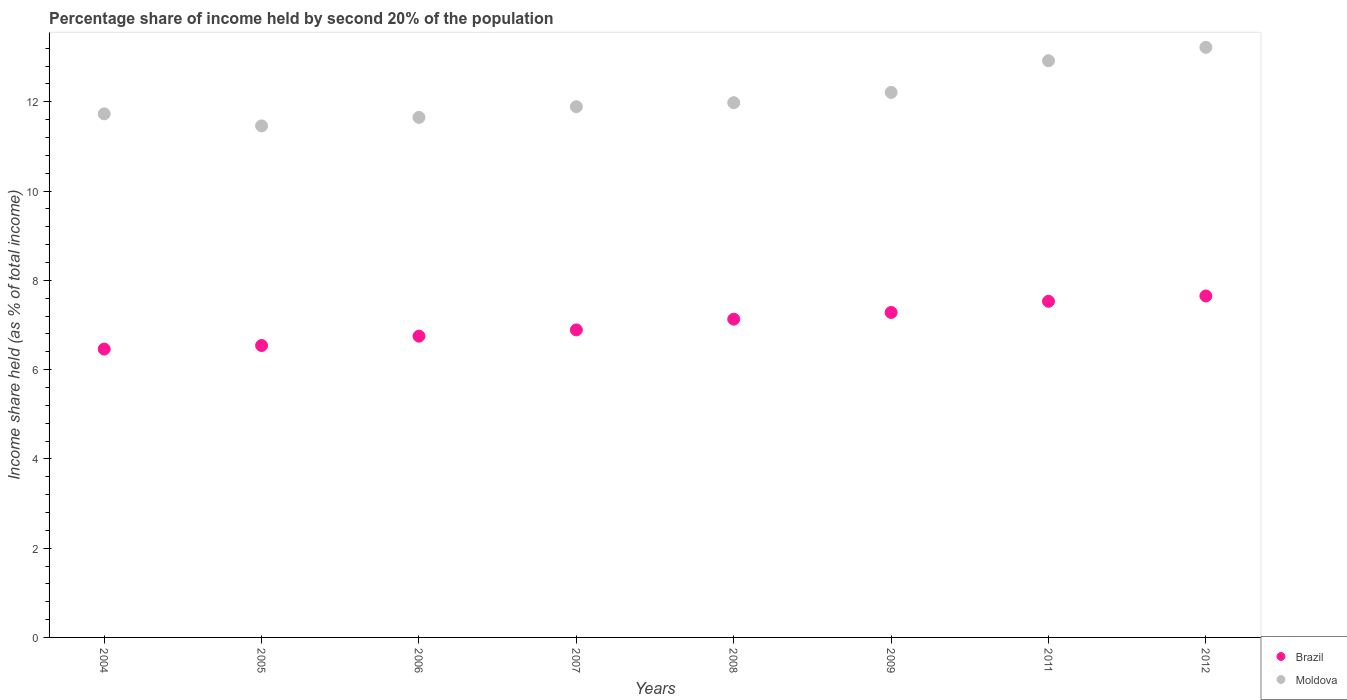How many different coloured dotlines are there?
Provide a short and direct response. 2. What is the share of income held by second 20% of the population in Moldova in 2007?
Make the answer very short. 11.89. Across all years, what is the maximum share of income held by second 20% of the population in Moldova?
Ensure brevity in your answer.  13.22. Across all years, what is the minimum share of income held by second 20% of the population in Moldova?
Offer a very short reply. 11.46. What is the total share of income held by second 20% of the population in Moldova in the graph?
Give a very brief answer. 97.06. What is the difference between the share of income held by second 20% of the population in Moldova in 2005 and that in 2011?
Your answer should be compact. -1.46. What is the difference between the share of income held by second 20% of the population in Moldova in 2006 and the share of income held by second 20% of the population in Brazil in 2009?
Offer a terse response. 4.37. What is the average share of income held by second 20% of the population in Moldova per year?
Make the answer very short. 12.13. In the year 2006, what is the difference between the share of income held by second 20% of the population in Brazil and share of income held by second 20% of the population in Moldova?
Offer a very short reply. -4.9. In how many years, is the share of income held by second 20% of the population in Brazil greater than 1.6 %?
Offer a terse response. 8. What is the ratio of the share of income held by second 20% of the population in Moldova in 2005 to that in 2009?
Your answer should be very brief. 0.94. Is the difference between the share of income held by second 20% of the population in Brazil in 2004 and 2009 greater than the difference between the share of income held by second 20% of the population in Moldova in 2004 and 2009?
Your answer should be compact. No. What is the difference between the highest and the second highest share of income held by second 20% of the population in Moldova?
Offer a very short reply. 0.3. What is the difference between the highest and the lowest share of income held by second 20% of the population in Moldova?
Give a very brief answer. 1.76. In how many years, is the share of income held by second 20% of the population in Moldova greater than the average share of income held by second 20% of the population in Moldova taken over all years?
Your answer should be very brief. 3. Is the share of income held by second 20% of the population in Moldova strictly greater than the share of income held by second 20% of the population in Brazil over the years?
Provide a succinct answer. Yes. What is the difference between two consecutive major ticks on the Y-axis?
Ensure brevity in your answer.  2. Does the graph contain grids?
Offer a very short reply. No. How many legend labels are there?
Provide a short and direct response. 2. What is the title of the graph?
Make the answer very short. Percentage share of income held by second 20% of the population. What is the label or title of the X-axis?
Your answer should be compact. Years. What is the label or title of the Y-axis?
Provide a short and direct response. Income share held (as % of total income). What is the Income share held (as % of total income) in Brazil in 2004?
Your response must be concise. 6.46. What is the Income share held (as % of total income) in Moldova in 2004?
Offer a very short reply. 11.73. What is the Income share held (as % of total income) in Brazil in 2005?
Your answer should be compact. 6.54. What is the Income share held (as % of total income) of Moldova in 2005?
Make the answer very short. 11.46. What is the Income share held (as % of total income) of Brazil in 2006?
Your answer should be compact. 6.75. What is the Income share held (as % of total income) in Moldova in 2006?
Your response must be concise. 11.65. What is the Income share held (as % of total income) in Brazil in 2007?
Your answer should be very brief. 6.89. What is the Income share held (as % of total income) of Moldova in 2007?
Your answer should be very brief. 11.89. What is the Income share held (as % of total income) in Brazil in 2008?
Keep it short and to the point. 7.13. What is the Income share held (as % of total income) in Moldova in 2008?
Make the answer very short. 11.98. What is the Income share held (as % of total income) in Brazil in 2009?
Your answer should be very brief. 7.28. What is the Income share held (as % of total income) of Moldova in 2009?
Make the answer very short. 12.21. What is the Income share held (as % of total income) in Brazil in 2011?
Provide a succinct answer. 7.53. What is the Income share held (as % of total income) of Moldova in 2011?
Ensure brevity in your answer.  12.92. What is the Income share held (as % of total income) in Brazil in 2012?
Keep it short and to the point. 7.65. What is the Income share held (as % of total income) of Moldova in 2012?
Give a very brief answer. 13.22. Across all years, what is the maximum Income share held (as % of total income) of Brazil?
Your response must be concise. 7.65. Across all years, what is the maximum Income share held (as % of total income) in Moldova?
Your answer should be very brief. 13.22. Across all years, what is the minimum Income share held (as % of total income) of Brazil?
Your answer should be compact. 6.46. Across all years, what is the minimum Income share held (as % of total income) in Moldova?
Offer a terse response. 11.46. What is the total Income share held (as % of total income) of Brazil in the graph?
Provide a succinct answer. 56.23. What is the total Income share held (as % of total income) of Moldova in the graph?
Ensure brevity in your answer.  97.06. What is the difference between the Income share held (as % of total income) in Brazil in 2004 and that in 2005?
Offer a very short reply. -0.08. What is the difference between the Income share held (as % of total income) of Moldova in 2004 and that in 2005?
Your response must be concise. 0.27. What is the difference between the Income share held (as % of total income) in Brazil in 2004 and that in 2006?
Keep it short and to the point. -0.29. What is the difference between the Income share held (as % of total income) of Brazil in 2004 and that in 2007?
Ensure brevity in your answer.  -0.43. What is the difference between the Income share held (as % of total income) in Moldova in 2004 and that in 2007?
Provide a succinct answer. -0.16. What is the difference between the Income share held (as % of total income) of Brazil in 2004 and that in 2008?
Make the answer very short. -0.67. What is the difference between the Income share held (as % of total income) of Moldova in 2004 and that in 2008?
Provide a short and direct response. -0.25. What is the difference between the Income share held (as % of total income) in Brazil in 2004 and that in 2009?
Offer a very short reply. -0.82. What is the difference between the Income share held (as % of total income) of Moldova in 2004 and that in 2009?
Offer a very short reply. -0.48. What is the difference between the Income share held (as % of total income) in Brazil in 2004 and that in 2011?
Give a very brief answer. -1.07. What is the difference between the Income share held (as % of total income) in Moldova in 2004 and that in 2011?
Your response must be concise. -1.19. What is the difference between the Income share held (as % of total income) of Brazil in 2004 and that in 2012?
Your answer should be very brief. -1.19. What is the difference between the Income share held (as % of total income) in Moldova in 2004 and that in 2012?
Provide a succinct answer. -1.49. What is the difference between the Income share held (as % of total income) in Brazil in 2005 and that in 2006?
Give a very brief answer. -0.21. What is the difference between the Income share held (as % of total income) in Moldova in 2005 and that in 2006?
Give a very brief answer. -0.19. What is the difference between the Income share held (as % of total income) of Brazil in 2005 and that in 2007?
Your response must be concise. -0.35. What is the difference between the Income share held (as % of total income) of Moldova in 2005 and that in 2007?
Your answer should be compact. -0.43. What is the difference between the Income share held (as % of total income) in Brazil in 2005 and that in 2008?
Your answer should be very brief. -0.59. What is the difference between the Income share held (as % of total income) in Moldova in 2005 and that in 2008?
Your answer should be very brief. -0.52. What is the difference between the Income share held (as % of total income) of Brazil in 2005 and that in 2009?
Provide a short and direct response. -0.74. What is the difference between the Income share held (as % of total income) of Moldova in 2005 and that in 2009?
Keep it short and to the point. -0.75. What is the difference between the Income share held (as % of total income) in Brazil in 2005 and that in 2011?
Your answer should be compact. -0.99. What is the difference between the Income share held (as % of total income) in Moldova in 2005 and that in 2011?
Keep it short and to the point. -1.46. What is the difference between the Income share held (as % of total income) in Brazil in 2005 and that in 2012?
Offer a terse response. -1.11. What is the difference between the Income share held (as % of total income) in Moldova in 2005 and that in 2012?
Your answer should be very brief. -1.76. What is the difference between the Income share held (as % of total income) in Brazil in 2006 and that in 2007?
Provide a succinct answer. -0.14. What is the difference between the Income share held (as % of total income) in Moldova in 2006 and that in 2007?
Offer a terse response. -0.24. What is the difference between the Income share held (as % of total income) in Brazil in 2006 and that in 2008?
Ensure brevity in your answer.  -0.38. What is the difference between the Income share held (as % of total income) of Moldova in 2006 and that in 2008?
Your answer should be very brief. -0.33. What is the difference between the Income share held (as % of total income) of Brazil in 2006 and that in 2009?
Keep it short and to the point. -0.53. What is the difference between the Income share held (as % of total income) in Moldova in 2006 and that in 2009?
Offer a terse response. -0.56. What is the difference between the Income share held (as % of total income) in Brazil in 2006 and that in 2011?
Offer a terse response. -0.78. What is the difference between the Income share held (as % of total income) of Moldova in 2006 and that in 2011?
Your response must be concise. -1.27. What is the difference between the Income share held (as % of total income) of Moldova in 2006 and that in 2012?
Ensure brevity in your answer.  -1.57. What is the difference between the Income share held (as % of total income) of Brazil in 2007 and that in 2008?
Provide a succinct answer. -0.24. What is the difference between the Income share held (as % of total income) of Moldova in 2007 and that in 2008?
Your answer should be very brief. -0.09. What is the difference between the Income share held (as % of total income) in Brazil in 2007 and that in 2009?
Keep it short and to the point. -0.39. What is the difference between the Income share held (as % of total income) of Moldova in 2007 and that in 2009?
Provide a short and direct response. -0.32. What is the difference between the Income share held (as % of total income) in Brazil in 2007 and that in 2011?
Make the answer very short. -0.64. What is the difference between the Income share held (as % of total income) of Moldova in 2007 and that in 2011?
Your answer should be compact. -1.03. What is the difference between the Income share held (as % of total income) of Brazil in 2007 and that in 2012?
Offer a very short reply. -0.76. What is the difference between the Income share held (as % of total income) of Moldova in 2007 and that in 2012?
Make the answer very short. -1.33. What is the difference between the Income share held (as % of total income) of Moldova in 2008 and that in 2009?
Provide a short and direct response. -0.23. What is the difference between the Income share held (as % of total income) of Brazil in 2008 and that in 2011?
Keep it short and to the point. -0.4. What is the difference between the Income share held (as % of total income) of Moldova in 2008 and that in 2011?
Your answer should be very brief. -0.94. What is the difference between the Income share held (as % of total income) in Brazil in 2008 and that in 2012?
Provide a succinct answer. -0.52. What is the difference between the Income share held (as % of total income) in Moldova in 2008 and that in 2012?
Make the answer very short. -1.24. What is the difference between the Income share held (as % of total income) in Moldova in 2009 and that in 2011?
Provide a short and direct response. -0.71. What is the difference between the Income share held (as % of total income) of Brazil in 2009 and that in 2012?
Your response must be concise. -0.37. What is the difference between the Income share held (as % of total income) of Moldova in 2009 and that in 2012?
Give a very brief answer. -1.01. What is the difference between the Income share held (as % of total income) in Brazil in 2011 and that in 2012?
Ensure brevity in your answer.  -0.12. What is the difference between the Income share held (as % of total income) of Moldova in 2011 and that in 2012?
Ensure brevity in your answer.  -0.3. What is the difference between the Income share held (as % of total income) of Brazil in 2004 and the Income share held (as % of total income) of Moldova in 2006?
Your answer should be very brief. -5.19. What is the difference between the Income share held (as % of total income) in Brazil in 2004 and the Income share held (as % of total income) in Moldova in 2007?
Your answer should be very brief. -5.43. What is the difference between the Income share held (as % of total income) of Brazil in 2004 and the Income share held (as % of total income) of Moldova in 2008?
Provide a short and direct response. -5.52. What is the difference between the Income share held (as % of total income) in Brazil in 2004 and the Income share held (as % of total income) in Moldova in 2009?
Your answer should be very brief. -5.75. What is the difference between the Income share held (as % of total income) in Brazil in 2004 and the Income share held (as % of total income) in Moldova in 2011?
Offer a terse response. -6.46. What is the difference between the Income share held (as % of total income) of Brazil in 2004 and the Income share held (as % of total income) of Moldova in 2012?
Your answer should be compact. -6.76. What is the difference between the Income share held (as % of total income) of Brazil in 2005 and the Income share held (as % of total income) of Moldova in 2006?
Your answer should be very brief. -5.11. What is the difference between the Income share held (as % of total income) of Brazil in 2005 and the Income share held (as % of total income) of Moldova in 2007?
Your answer should be very brief. -5.35. What is the difference between the Income share held (as % of total income) in Brazil in 2005 and the Income share held (as % of total income) in Moldova in 2008?
Your answer should be compact. -5.44. What is the difference between the Income share held (as % of total income) in Brazil in 2005 and the Income share held (as % of total income) in Moldova in 2009?
Provide a succinct answer. -5.67. What is the difference between the Income share held (as % of total income) of Brazil in 2005 and the Income share held (as % of total income) of Moldova in 2011?
Your response must be concise. -6.38. What is the difference between the Income share held (as % of total income) in Brazil in 2005 and the Income share held (as % of total income) in Moldova in 2012?
Ensure brevity in your answer.  -6.68. What is the difference between the Income share held (as % of total income) of Brazil in 2006 and the Income share held (as % of total income) of Moldova in 2007?
Give a very brief answer. -5.14. What is the difference between the Income share held (as % of total income) in Brazil in 2006 and the Income share held (as % of total income) in Moldova in 2008?
Your answer should be very brief. -5.23. What is the difference between the Income share held (as % of total income) in Brazil in 2006 and the Income share held (as % of total income) in Moldova in 2009?
Your response must be concise. -5.46. What is the difference between the Income share held (as % of total income) of Brazil in 2006 and the Income share held (as % of total income) of Moldova in 2011?
Provide a succinct answer. -6.17. What is the difference between the Income share held (as % of total income) of Brazil in 2006 and the Income share held (as % of total income) of Moldova in 2012?
Keep it short and to the point. -6.47. What is the difference between the Income share held (as % of total income) in Brazil in 2007 and the Income share held (as % of total income) in Moldova in 2008?
Ensure brevity in your answer.  -5.09. What is the difference between the Income share held (as % of total income) of Brazil in 2007 and the Income share held (as % of total income) of Moldova in 2009?
Ensure brevity in your answer.  -5.32. What is the difference between the Income share held (as % of total income) of Brazil in 2007 and the Income share held (as % of total income) of Moldova in 2011?
Ensure brevity in your answer.  -6.03. What is the difference between the Income share held (as % of total income) in Brazil in 2007 and the Income share held (as % of total income) in Moldova in 2012?
Keep it short and to the point. -6.33. What is the difference between the Income share held (as % of total income) of Brazil in 2008 and the Income share held (as % of total income) of Moldova in 2009?
Make the answer very short. -5.08. What is the difference between the Income share held (as % of total income) in Brazil in 2008 and the Income share held (as % of total income) in Moldova in 2011?
Make the answer very short. -5.79. What is the difference between the Income share held (as % of total income) in Brazil in 2008 and the Income share held (as % of total income) in Moldova in 2012?
Offer a very short reply. -6.09. What is the difference between the Income share held (as % of total income) of Brazil in 2009 and the Income share held (as % of total income) of Moldova in 2011?
Give a very brief answer. -5.64. What is the difference between the Income share held (as % of total income) in Brazil in 2009 and the Income share held (as % of total income) in Moldova in 2012?
Ensure brevity in your answer.  -5.94. What is the difference between the Income share held (as % of total income) of Brazil in 2011 and the Income share held (as % of total income) of Moldova in 2012?
Ensure brevity in your answer.  -5.69. What is the average Income share held (as % of total income) in Brazil per year?
Provide a succinct answer. 7.03. What is the average Income share held (as % of total income) in Moldova per year?
Provide a short and direct response. 12.13. In the year 2004, what is the difference between the Income share held (as % of total income) of Brazil and Income share held (as % of total income) of Moldova?
Provide a succinct answer. -5.27. In the year 2005, what is the difference between the Income share held (as % of total income) of Brazil and Income share held (as % of total income) of Moldova?
Keep it short and to the point. -4.92. In the year 2006, what is the difference between the Income share held (as % of total income) of Brazil and Income share held (as % of total income) of Moldova?
Offer a terse response. -4.9. In the year 2007, what is the difference between the Income share held (as % of total income) of Brazil and Income share held (as % of total income) of Moldova?
Provide a short and direct response. -5. In the year 2008, what is the difference between the Income share held (as % of total income) of Brazil and Income share held (as % of total income) of Moldova?
Keep it short and to the point. -4.85. In the year 2009, what is the difference between the Income share held (as % of total income) of Brazil and Income share held (as % of total income) of Moldova?
Your response must be concise. -4.93. In the year 2011, what is the difference between the Income share held (as % of total income) of Brazil and Income share held (as % of total income) of Moldova?
Ensure brevity in your answer.  -5.39. In the year 2012, what is the difference between the Income share held (as % of total income) in Brazil and Income share held (as % of total income) in Moldova?
Keep it short and to the point. -5.57. What is the ratio of the Income share held (as % of total income) in Moldova in 2004 to that in 2005?
Make the answer very short. 1.02. What is the ratio of the Income share held (as % of total income) of Brazil in 2004 to that in 2006?
Offer a terse response. 0.96. What is the ratio of the Income share held (as % of total income) of Moldova in 2004 to that in 2006?
Your answer should be very brief. 1.01. What is the ratio of the Income share held (as % of total income) of Brazil in 2004 to that in 2007?
Make the answer very short. 0.94. What is the ratio of the Income share held (as % of total income) in Moldova in 2004 to that in 2007?
Offer a terse response. 0.99. What is the ratio of the Income share held (as % of total income) of Brazil in 2004 to that in 2008?
Offer a terse response. 0.91. What is the ratio of the Income share held (as % of total income) in Moldova in 2004 to that in 2008?
Offer a terse response. 0.98. What is the ratio of the Income share held (as % of total income) in Brazil in 2004 to that in 2009?
Give a very brief answer. 0.89. What is the ratio of the Income share held (as % of total income) of Moldova in 2004 to that in 2009?
Offer a very short reply. 0.96. What is the ratio of the Income share held (as % of total income) of Brazil in 2004 to that in 2011?
Keep it short and to the point. 0.86. What is the ratio of the Income share held (as % of total income) in Moldova in 2004 to that in 2011?
Provide a succinct answer. 0.91. What is the ratio of the Income share held (as % of total income) in Brazil in 2004 to that in 2012?
Give a very brief answer. 0.84. What is the ratio of the Income share held (as % of total income) of Moldova in 2004 to that in 2012?
Your answer should be very brief. 0.89. What is the ratio of the Income share held (as % of total income) of Brazil in 2005 to that in 2006?
Provide a succinct answer. 0.97. What is the ratio of the Income share held (as % of total income) in Moldova in 2005 to that in 2006?
Offer a terse response. 0.98. What is the ratio of the Income share held (as % of total income) in Brazil in 2005 to that in 2007?
Make the answer very short. 0.95. What is the ratio of the Income share held (as % of total income) of Moldova in 2005 to that in 2007?
Give a very brief answer. 0.96. What is the ratio of the Income share held (as % of total income) in Brazil in 2005 to that in 2008?
Keep it short and to the point. 0.92. What is the ratio of the Income share held (as % of total income) of Moldova in 2005 to that in 2008?
Make the answer very short. 0.96. What is the ratio of the Income share held (as % of total income) in Brazil in 2005 to that in 2009?
Offer a very short reply. 0.9. What is the ratio of the Income share held (as % of total income) in Moldova in 2005 to that in 2009?
Make the answer very short. 0.94. What is the ratio of the Income share held (as % of total income) of Brazil in 2005 to that in 2011?
Your answer should be compact. 0.87. What is the ratio of the Income share held (as % of total income) in Moldova in 2005 to that in 2011?
Provide a short and direct response. 0.89. What is the ratio of the Income share held (as % of total income) in Brazil in 2005 to that in 2012?
Keep it short and to the point. 0.85. What is the ratio of the Income share held (as % of total income) in Moldova in 2005 to that in 2012?
Make the answer very short. 0.87. What is the ratio of the Income share held (as % of total income) in Brazil in 2006 to that in 2007?
Your response must be concise. 0.98. What is the ratio of the Income share held (as % of total income) in Moldova in 2006 to that in 2007?
Your answer should be very brief. 0.98. What is the ratio of the Income share held (as % of total income) in Brazil in 2006 to that in 2008?
Provide a succinct answer. 0.95. What is the ratio of the Income share held (as % of total income) in Moldova in 2006 to that in 2008?
Give a very brief answer. 0.97. What is the ratio of the Income share held (as % of total income) of Brazil in 2006 to that in 2009?
Give a very brief answer. 0.93. What is the ratio of the Income share held (as % of total income) of Moldova in 2006 to that in 2009?
Keep it short and to the point. 0.95. What is the ratio of the Income share held (as % of total income) in Brazil in 2006 to that in 2011?
Keep it short and to the point. 0.9. What is the ratio of the Income share held (as % of total income) of Moldova in 2006 to that in 2011?
Your answer should be compact. 0.9. What is the ratio of the Income share held (as % of total income) in Brazil in 2006 to that in 2012?
Your response must be concise. 0.88. What is the ratio of the Income share held (as % of total income) of Moldova in 2006 to that in 2012?
Make the answer very short. 0.88. What is the ratio of the Income share held (as % of total income) in Brazil in 2007 to that in 2008?
Ensure brevity in your answer.  0.97. What is the ratio of the Income share held (as % of total income) in Brazil in 2007 to that in 2009?
Provide a short and direct response. 0.95. What is the ratio of the Income share held (as % of total income) of Moldova in 2007 to that in 2009?
Your answer should be compact. 0.97. What is the ratio of the Income share held (as % of total income) of Brazil in 2007 to that in 2011?
Your answer should be very brief. 0.92. What is the ratio of the Income share held (as % of total income) of Moldova in 2007 to that in 2011?
Ensure brevity in your answer.  0.92. What is the ratio of the Income share held (as % of total income) in Brazil in 2007 to that in 2012?
Your answer should be very brief. 0.9. What is the ratio of the Income share held (as % of total income) of Moldova in 2007 to that in 2012?
Your answer should be very brief. 0.9. What is the ratio of the Income share held (as % of total income) of Brazil in 2008 to that in 2009?
Your answer should be very brief. 0.98. What is the ratio of the Income share held (as % of total income) of Moldova in 2008 to that in 2009?
Provide a short and direct response. 0.98. What is the ratio of the Income share held (as % of total income) in Brazil in 2008 to that in 2011?
Offer a terse response. 0.95. What is the ratio of the Income share held (as % of total income) of Moldova in 2008 to that in 2011?
Provide a short and direct response. 0.93. What is the ratio of the Income share held (as % of total income) in Brazil in 2008 to that in 2012?
Your answer should be very brief. 0.93. What is the ratio of the Income share held (as % of total income) of Moldova in 2008 to that in 2012?
Offer a very short reply. 0.91. What is the ratio of the Income share held (as % of total income) of Brazil in 2009 to that in 2011?
Give a very brief answer. 0.97. What is the ratio of the Income share held (as % of total income) in Moldova in 2009 to that in 2011?
Offer a terse response. 0.94. What is the ratio of the Income share held (as % of total income) of Brazil in 2009 to that in 2012?
Make the answer very short. 0.95. What is the ratio of the Income share held (as % of total income) of Moldova in 2009 to that in 2012?
Your answer should be compact. 0.92. What is the ratio of the Income share held (as % of total income) in Brazil in 2011 to that in 2012?
Offer a very short reply. 0.98. What is the ratio of the Income share held (as % of total income) of Moldova in 2011 to that in 2012?
Provide a succinct answer. 0.98. What is the difference between the highest and the second highest Income share held (as % of total income) of Brazil?
Offer a terse response. 0.12. What is the difference between the highest and the lowest Income share held (as % of total income) of Brazil?
Your answer should be very brief. 1.19. What is the difference between the highest and the lowest Income share held (as % of total income) of Moldova?
Ensure brevity in your answer.  1.76. 